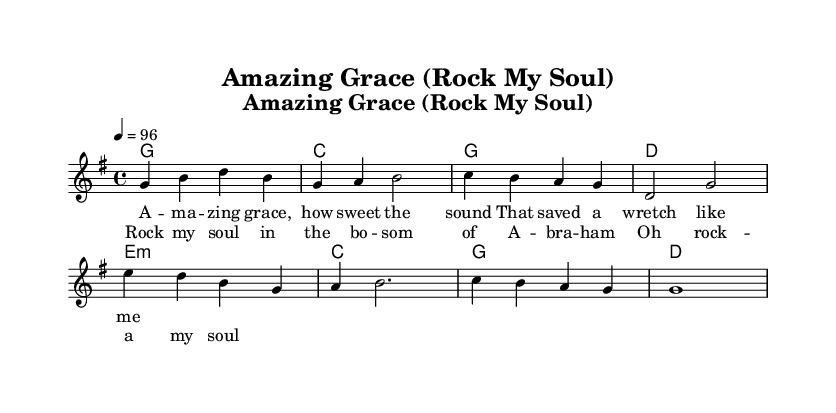What is the key signature of this music? The key signature is G major, indicated by the presence of one sharp (F#) in the score.
Answer: G major What is the time signature of this music? The time signature is 4/4, which is shown at the beginning of the score and indicates four beats in a measure.
Answer: 4/4 What is the tempo marking for this piece? The tempo marking is quarter note equals 96, provided at the beginning of the score, indicating the speed at which the music should be played.
Answer: 96 How many measures are there in the chorus section? The chorus section consists of four measures, as observed from the layout and grouping of notes under the chorus lyrics.
Answer: 4 What vocal style does this piece represent? The piece reflects a Southern rock style with gospel influences, evidenced by the themes in the lyrics and the chord progressions typical of the genre.
Answer: Southern rock What is the first lyric line of the verse? The first lyric line in the verse is "A - ma - zing grace, how sweet the sound," which is explicitly stated under the melody staff in the score.
Answer: A - ma - zing grace, how sweet the sound What harmonies are played with the chorus section? The chorus section is accompanied by the chords E minor, C major, G major, and D major, as indicated in the chord symbols below the melody.
Answer: E minor, C major, G major, D major 